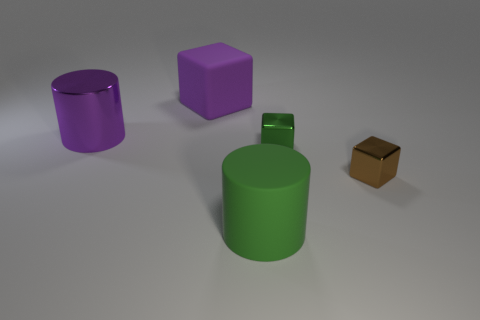Add 3 big rubber cylinders. How many objects exist? 8 Subtract all cubes. How many objects are left? 2 Subtract all large metal things. Subtract all green cubes. How many objects are left? 3 Add 5 purple metallic cylinders. How many purple metallic cylinders are left? 6 Add 2 yellow cylinders. How many yellow cylinders exist? 2 Subtract 0 brown spheres. How many objects are left? 5 